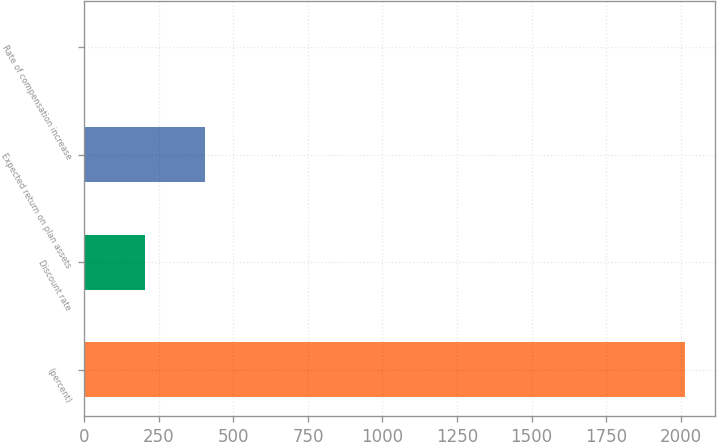<chart> <loc_0><loc_0><loc_500><loc_500><bar_chart><fcel>(percent)<fcel>Discount rate<fcel>Expected return on plan assets<fcel>Rate of compensation increase<nl><fcel>2014<fcel>203.89<fcel>405.01<fcel>2.77<nl></chart> 